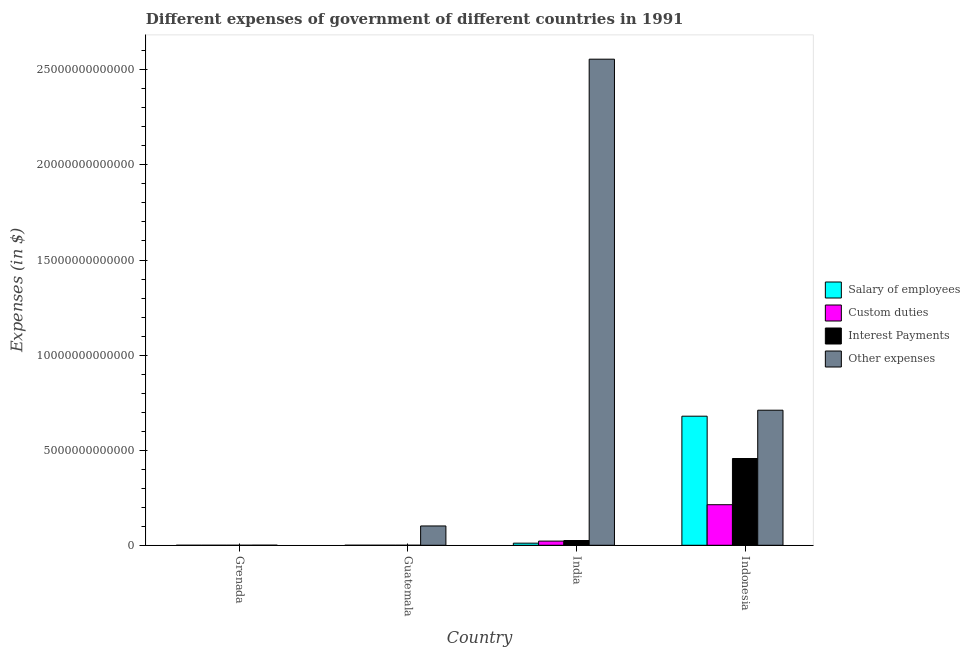How many different coloured bars are there?
Offer a very short reply. 4. How many groups of bars are there?
Ensure brevity in your answer.  4. Are the number of bars per tick equal to the number of legend labels?
Provide a short and direct response. Yes. Are the number of bars on each tick of the X-axis equal?
Your answer should be very brief. Yes. What is the label of the 2nd group of bars from the left?
Your response must be concise. Guatemala. What is the amount spent on interest payments in India?
Offer a terse response. 2.50e+11. Across all countries, what is the maximum amount spent on salary of employees?
Provide a succinct answer. 6.79e+12. Across all countries, what is the minimum amount spent on interest payments?
Provide a short and direct response. 1.28e+07. In which country was the amount spent on custom duties minimum?
Provide a short and direct response. Grenada. What is the total amount spent on salary of employees in the graph?
Your response must be concise. 6.90e+12. What is the difference between the amount spent on other expenses in Guatemala and that in Indonesia?
Provide a succinct answer. -6.09e+12. What is the difference between the amount spent on other expenses in Grenada and the amount spent on interest payments in Guatemala?
Your answer should be very brief. 3.11e+09. What is the average amount spent on salary of employees per country?
Your response must be concise. 1.72e+12. What is the difference between the amount spent on custom duties and amount spent on interest payments in Indonesia?
Keep it short and to the point. -2.43e+12. What is the ratio of the amount spent on salary of employees in Grenada to that in Guatemala?
Ensure brevity in your answer.  0.07. Is the amount spent on interest payments in Grenada less than that in Indonesia?
Give a very brief answer. Yes. Is the difference between the amount spent on custom duties in Guatemala and Indonesia greater than the difference between the amount spent on interest payments in Guatemala and Indonesia?
Provide a succinct answer. Yes. What is the difference between the highest and the second highest amount spent on salary of employees?
Provide a short and direct response. 6.68e+12. What is the difference between the highest and the lowest amount spent on custom duties?
Provide a succinct answer. 2.13e+12. Is the sum of the amount spent on custom duties in Guatemala and Indonesia greater than the maximum amount spent on salary of employees across all countries?
Provide a short and direct response. No. Is it the case that in every country, the sum of the amount spent on salary of employees and amount spent on interest payments is greater than the sum of amount spent on other expenses and amount spent on custom duties?
Provide a short and direct response. No. What does the 1st bar from the left in Guatemala represents?
Give a very brief answer. Salary of employees. What does the 2nd bar from the right in Guatemala represents?
Keep it short and to the point. Interest Payments. Is it the case that in every country, the sum of the amount spent on salary of employees and amount spent on custom duties is greater than the amount spent on interest payments?
Offer a very short reply. Yes. How many countries are there in the graph?
Make the answer very short. 4. What is the difference between two consecutive major ticks on the Y-axis?
Keep it short and to the point. 5.00e+12. Are the values on the major ticks of Y-axis written in scientific E-notation?
Your answer should be very brief. No. Does the graph contain any zero values?
Ensure brevity in your answer.  No. What is the title of the graph?
Give a very brief answer. Different expenses of government of different countries in 1991. Does "Tertiary education" appear as one of the legend labels in the graph?
Offer a terse response. No. What is the label or title of the X-axis?
Ensure brevity in your answer.  Country. What is the label or title of the Y-axis?
Give a very brief answer. Expenses (in $). What is the Expenses (in $) in Salary of employees in Grenada?
Provide a succinct answer. 9.53e+07. What is the Expenses (in $) in Custom duties in Grenada?
Ensure brevity in your answer.  3.07e+07. What is the Expenses (in $) in Interest Payments in Grenada?
Make the answer very short. 1.28e+07. What is the Expenses (in $) in Other expenses in Grenada?
Provide a short and direct response. 3.86e+09. What is the Expenses (in $) of Salary of employees in Guatemala?
Your response must be concise. 1.36e+09. What is the Expenses (in $) of Custom duties in Guatemala?
Offer a terse response. 6.62e+08. What is the Expenses (in $) of Interest Payments in Guatemala?
Offer a very short reply. 7.53e+08. What is the Expenses (in $) in Other expenses in Guatemala?
Your response must be concise. 1.02e+12. What is the Expenses (in $) of Salary of employees in India?
Provide a succinct answer. 1.11e+11. What is the Expenses (in $) in Custom duties in India?
Ensure brevity in your answer.  2.20e+11. What is the Expenses (in $) in Interest Payments in India?
Offer a very short reply. 2.50e+11. What is the Expenses (in $) in Other expenses in India?
Keep it short and to the point. 2.56e+13. What is the Expenses (in $) in Salary of employees in Indonesia?
Your response must be concise. 6.79e+12. What is the Expenses (in $) in Custom duties in Indonesia?
Make the answer very short. 2.13e+12. What is the Expenses (in $) of Interest Payments in Indonesia?
Make the answer very short. 4.56e+12. What is the Expenses (in $) in Other expenses in Indonesia?
Provide a succinct answer. 7.10e+12. Across all countries, what is the maximum Expenses (in $) of Salary of employees?
Provide a short and direct response. 6.79e+12. Across all countries, what is the maximum Expenses (in $) in Custom duties?
Provide a short and direct response. 2.13e+12. Across all countries, what is the maximum Expenses (in $) of Interest Payments?
Your response must be concise. 4.56e+12. Across all countries, what is the maximum Expenses (in $) in Other expenses?
Keep it short and to the point. 2.56e+13. Across all countries, what is the minimum Expenses (in $) in Salary of employees?
Ensure brevity in your answer.  9.53e+07. Across all countries, what is the minimum Expenses (in $) of Custom duties?
Offer a very short reply. 3.07e+07. Across all countries, what is the minimum Expenses (in $) of Interest Payments?
Offer a terse response. 1.28e+07. Across all countries, what is the minimum Expenses (in $) of Other expenses?
Ensure brevity in your answer.  3.86e+09. What is the total Expenses (in $) of Salary of employees in the graph?
Offer a terse response. 6.90e+12. What is the total Expenses (in $) of Custom duties in the graph?
Your response must be concise. 2.35e+12. What is the total Expenses (in $) of Interest Payments in the graph?
Offer a very short reply. 4.81e+12. What is the total Expenses (in $) in Other expenses in the graph?
Offer a very short reply. 3.37e+13. What is the difference between the Expenses (in $) in Salary of employees in Grenada and that in Guatemala?
Provide a short and direct response. -1.27e+09. What is the difference between the Expenses (in $) of Custom duties in Grenada and that in Guatemala?
Your answer should be compact. -6.31e+08. What is the difference between the Expenses (in $) in Interest Payments in Grenada and that in Guatemala?
Provide a short and direct response. -7.40e+08. What is the difference between the Expenses (in $) in Other expenses in Grenada and that in Guatemala?
Provide a short and direct response. -1.01e+12. What is the difference between the Expenses (in $) in Salary of employees in Grenada and that in India?
Give a very brief answer. -1.11e+11. What is the difference between the Expenses (in $) in Custom duties in Grenada and that in India?
Make the answer very short. -2.20e+11. What is the difference between the Expenses (in $) of Interest Payments in Grenada and that in India?
Your answer should be very brief. -2.50e+11. What is the difference between the Expenses (in $) of Other expenses in Grenada and that in India?
Provide a short and direct response. -2.56e+13. What is the difference between the Expenses (in $) in Salary of employees in Grenada and that in Indonesia?
Your response must be concise. -6.79e+12. What is the difference between the Expenses (in $) of Custom duties in Grenada and that in Indonesia?
Ensure brevity in your answer.  -2.13e+12. What is the difference between the Expenses (in $) of Interest Payments in Grenada and that in Indonesia?
Provide a succinct answer. -4.56e+12. What is the difference between the Expenses (in $) in Other expenses in Grenada and that in Indonesia?
Your answer should be very brief. -7.10e+12. What is the difference between the Expenses (in $) of Salary of employees in Guatemala and that in India?
Make the answer very short. -1.09e+11. What is the difference between the Expenses (in $) of Custom duties in Guatemala and that in India?
Offer a very short reply. -2.19e+11. What is the difference between the Expenses (in $) in Interest Payments in Guatemala and that in India?
Your response must be concise. -2.49e+11. What is the difference between the Expenses (in $) in Other expenses in Guatemala and that in India?
Ensure brevity in your answer.  -2.45e+13. What is the difference between the Expenses (in $) of Salary of employees in Guatemala and that in Indonesia?
Your answer should be compact. -6.79e+12. What is the difference between the Expenses (in $) in Custom duties in Guatemala and that in Indonesia?
Give a very brief answer. -2.13e+12. What is the difference between the Expenses (in $) of Interest Payments in Guatemala and that in Indonesia?
Your response must be concise. -4.56e+12. What is the difference between the Expenses (in $) in Other expenses in Guatemala and that in Indonesia?
Keep it short and to the point. -6.09e+12. What is the difference between the Expenses (in $) of Salary of employees in India and that in Indonesia?
Offer a very short reply. -6.68e+12. What is the difference between the Expenses (in $) of Custom duties in India and that in Indonesia?
Provide a short and direct response. -1.91e+12. What is the difference between the Expenses (in $) in Interest Payments in India and that in Indonesia?
Your answer should be very brief. -4.31e+12. What is the difference between the Expenses (in $) in Other expenses in India and that in Indonesia?
Ensure brevity in your answer.  1.85e+13. What is the difference between the Expenses (in $) of Salary of employees in Grenada and the Expenses (in $) of Custom duties in Guatemala?
Provide a succinct answer. -5.67e+08. What is the difference between the Expenses (in $) of Salary of employees in Grenada and the Expenses (in $) of Interest Payments in Guatemala?
Make the answer very short. -6.57e+08. What is the difference between the Expenses (in $) in Salary of employees in Grenada and the Expenses (in $) in Other expenses in Guatemala?
Provide a succinct answer. -1.02e+12. What is the difference between the Expenses (in $) of Custom duties in Grenada and the Expenses (in $) of Interest Payments in Guatemala?
Offer a terse response. -7.22e+08. What is the difference between the Expenses (in $) of Custom duties in Grenada and the Expenses (in $) of Other expenses in Guatemala?
Offer a terse response. -1.02e+12. What is the difference between the Expenses (in $) in Interest Payments in Grenada and the Expenses (in $) in Other expenses in Guatemala?
Your response must be concise. -1.02e+12. What is the difference between the Expenses (in $) of Salary of employees in Grenada and the Expenses (in $) of Custom duties in India?
Your response must be concise. -2.20e+11. What is the difference between the Expenses (in $) of Salary of employees in Grenada and the Expenses (in $) of Interest Payments in India?
Your answer should be very brief. -2.49e+11. What is the difference between the Expenses (in $) in Salary of employees in Grenada and the Expenses (in $) in Other expenses in India?
Ensure brevity in your answer.  -2.56e+13. What is the difference between the Expenses (in $) of Custom duties in Grenada and the Expenses (in $) of Interest Payments in India?
Offer a very short reply. -2.50e+11. What is the difference between the Expenses (in $) in Custom duties in Grenada and the Expenses (in $) in Other expenses in India?
Offer a very short reply. -2.56e+13. What is the difference between the Expenses (in $) of Interest Payments in Grenada and the Expenses (in $) of Other expenses in India?
Your answer should be very brief. -2.56e+13. What is the difference between the Expenses (in $) of Salary of employees in Grenada and the Expenses (in $) of Custom duties in Indonesia?
Offer a very short reply. -2.13e+12. What is the difference between the Expenses (in $) of Salary of employees in Grenada and the Expenses (in $) of Interest Payments in Indonesia?
Offer a terse response. -4.56e+12. What is the difference between the Expenses (in $) of Salary of employees in Grenada and the Expenses (in $) of Other expenses in Indonesia?
Your answer should be compact. -7.10e+12. What is the difference between the Expenses (in $) in Custom duties in Grenada and the Expenses (in $) in Interest Payments in Indonesia?
Offer a very short reply. -4.56e+12. What is the difference between the Expenses (in $) in Custom duties in Grenada and the Expenses (in $) in Other expenses in Indonesia?
Give a very brief answer. -7.10e+12. What is the difference between the Expenses (in $) in Interest Payments in Grenada and the Expenses (in $) in Other expenses in Indonesia?
Ensure brevity in your answer.  -7.10e+12. What is the difference between the Expenses (in $) of Salary of employees in Guatemala and the Expenses (in $) of Custom duties in India?
Your answer should be compact. -2.18e+11. What is the difference between the Expenses (in $) of Salary of employees in Guatemala and the Expenses (in $) of Interest Payments in India?
Provide a short and direct response. -2.48e+11. What is the difference between the Expenses (in $) of Salary of employees in Guatemala and the Expenses (in $) of Other expenses in India?
Your response must be concise. -2.56e+13. What is the difference between the Expenses (in $) in Custom duties in Guatemala and the Expenses (in $) in Interest Payments in India?
Give a very brief answer. -2.49e+11. What is the difference between the Expenses (in $) of Custom duties in Guatemala and the Expenses (in $) of Other expenses in India?
Provide a succinct answer. -2.56e+13. What is the difference between the Expenses (in $) of Interest Payments in Guatemala and the Expenses (in $) of Other expenses in India?
Make the answer very short. -2.56e+13. What is the difference between the Expenses (in $) of Salary of employees in Guatemala and the Expenses (in $) of Custom duties in Indonesia?
Provide a short and direct response. -2.13e+12. What is the difference between the Expenses (in $) of Salary of employees in Guatemala and the Expenses (in $) of Interest Payments in Indonesia?
Your response must be concise. -4.56e+12. What is the difference between the Expenses (in $) in Salary of employees in Guatemala and the Expenses (in $) in Other expenses in Indonesia?
Your answer should be very brief. -7.10e+12. What is the difference between the Expenses (in $) of Custom duties in Guatemala and the Expenses (in $) of Interest Payments in Indonesia?
Your answer should be compact. -4.56e+12. What is the difference between the Expenses (in $) of Custom duties in Guatemala and the Expenses (in $) of Other expenses in Indonesia?
Offer a very short reply. -7.10e+12. What is the difference between the Expenses (in $) in Interest Payments in Guatemala and the Expenses (in $) in Other expenses in Indonesia?
Your answer should be very brief. -7.10e+12. What is the difference between the Expenses (in $) of Salary of employees in India and the Expenses (in $) of Custom duties in Indonesia?
Give a very brief answer. -2.02e+12. What is the difference between the Expenses (in $) of Salary of employees in India and the Expenses (in $) of Interest Payments in Indonesia?
Offer a very short reply. -4.45e+12. What is the difference between the Expenses (in $) of Salary of employees in India and the Expenses (in $) of Other expenses in Indonesia?
Provide a succinct answer. -6.99e+12. What is the difference between the Expenses (in $) of Custom duties in India and the Expenses (in $) of Interest Payments in Indonesia?
Your response must be concise. -4.34e+12. What is the difference between the Expenses (in $) in Custom duties in India and the Expenses (in $) in Other expenses in Indonesia?
Your response must be concise. -6.88e+12. What is the difference between the Expenses (in $) in Interest Payments in India and the Expenses (in $) in Other expenses in Indonesia?
Offer a terse response. -6.85e+12. What is the average Expenses (in $) in Salary of employees per country?
Ensure brevity in your answer.  1.72e+12. What is the average Expenses (in $) of Custom duties per country?
Offer a very short reply. 5.88e+11. What is the average Expenses (in $) in Interest Payments per country?
Offer a very short reply. 1.20e+12. What is the average Expenses (in $) of Other expenses per country?
Offer a very short reply. 8.42e+12. What is the difference between the Expenses (in $) in Salary of employees and Expenses (in $) in Custom duties in Grenada?
Give a very brief answer. 6.46e+07. What is the difference between the Expenses (in $) in Salary of employees and Expenses (in $) in Interest Payments in Grenada?
Keep it short and to the point. 8.24e+07. What is the difference between the Expenses (in $) of Salary of employees and Expenses (in $) of Other expenses in Grenada?
Provide a short and direct response. -3.76e+09. What is the difference between the Expenses (in $) in Custom duties and Expenses (in $) in Interest Payments in Grenada?
Keep it short and to the point. 1.79e+07. What is the difference between the Expenses (in $) in Custom duties and Expenses (in $) in Other expenses in Grenada?
Your answer should be very brief. -3.83e+09. What is the difference between the Expenses (in $) in Interest Payments and Expenses (in $) in Other expenses in Grenada?
Provide a short and direct response. -3.85e+09. What is the difference between the Expenses (in $) of Salary of employees and Expenses (in $) of Custom duties in Guatemala?
Give a very brief answer. 7.02e+08. What is the difference between the Expenses (in $) in Salary of employees and Expenses (in $) in Interest Payments in Guatemala?
Offer a very short reply. 6.12e+08. What is the difference between the Expenses (in $) of Salary of employees and Expenses (in $) of Other expenses in Guatemala?
Your response must be concise. -1.01e+12. What is the difference between the Expenses (in $) in Custom duties and Expenses (in $) in Interest Payments in Guatemala?
Your response must be concise. -9.05e+07. What is the difference between the Expenses (in $) in Custom duties and Expenses (in $) in Other expenses in Guatemala?
Give a very brief answer. -1.02e+12. What is the difference between the Expenses (in $) of Interest Payments and Expenses (in $) of Other expenses in Guatemala?
Offer a terse response. -1.02e+12. What is the difference between the Expenses (in $) of Salary of employees and Expenses (in $) of Custom duties in India?
Make the answer very short. -1.09e+11. What is the difference between the Expenses (in $) of Salary of employees and Expenses (in $) of Interest Payments in India?
Offer a terse response. -1.39e+11. What is the difference between the Expenses (in $) in Salary of employees and Expenses (in $) in Other expenses in India?
Make the answer very short. -2.54e+13. What is the difference between the Expenses (in $) in Custom duties and Expenses (in $) in Interest Payments in India?
Give a very brief answer. -2.98e+1. What is the difference between the Expenses (in $) in Custom duties and Expenses (in $) in Other expenses in India?
Your answer should be very brief. -2.53e+13. What is the difference between the Expenses (in $) of Interest Payments and Expenses (in $) of Other expenses in India?
Your answer should be very brief. -2.53e+13. What is the difference between the Expenses (in $) in Salary of employees and Expenses (in $) in Custom duties in Indonesia?
Ensure brevity in your answer.  4.65e+12. What is the difference between the Expenses (in $) of Salary of employees and Expenses (in $) of Interest Payments in Indonesia?
Your answer should be compact. 2.22e+12. What is the difference between the Expenses (in $) in Salary of employees and Expenses (in $) in Other expenses in Indonesia?
Keep it short and to the point. -3.15e+11. What is the difference between the Expenses (in $) of Custom duties and Expenses (in $) of Interest Payments in Indonesia?
Keep it short and to the point. -2.43e+12. What is the difference between the Expenses (in $) in Custom duties and Expenses (in $) in Other expenses in Indonesia?
Your response must be concise. -4.97e+12. What is the difference between the Expenses (in $) in Interest Payments and Expenses (in $) in Other expenses in Indonesia?
Your response must be concise. -2.54e+12. What is the ratio of the Expenses (in $) in Salary of employees in Grenada to that in Guatemala?
Your response must be concise. 0.07. What is the ratio of the Expenses (in $) of Custom duties in Grenada to that in Guatemala?
Offer a terse response. 0.05. What is the ratio of the Expenses (in $) of Interest Payments in Grenada to that in Guatemala?
Provide a short and direct response. 0.02. What is the ratio of the Expenses (in $) in Other expenses in Grenada to that in Guatemala?
Provide a succinct answer. 0. What is the ratio of the Expenses (in $) in Salary of employees in Grenada to that in India?
Provide a succinct answer. 0. What is the ratio of the Expenses (in $) in Interest Payments in Grenada to that in India?
Keep it short and to the point. 0. What is the ratio of the Expenses (in $) in Other expenses in Grenada to that in India?
Make the answer very short. 0. What is the ratio of the Expenses (in $) in Salary of employees in Grenada to that in Indonesia?
Ensure brevity in your answer.  0. What is the ratio of the Expenses (in $) of Custom duties in Grenada to that in Indonesia?
Your response must be concise. 0. What is the ratio of the Expenses (in $) in Other expenses in Grenada to that in Indonesia?
Your answer should be compact. 0. What is the ratio of the Expenses (in $) of Salary of employees in Guatemala to that in India?
Provide a short and direct response. 0.01. What is the ratio of the Expenses (in $) of Custom duties in Guatemala to that in India?
Give a very brief answer. 0. What is the ratio of the Expenses (in $) of Interest Payments in Guatemala to that in India?
Provide a succinct answer. 0. What is the ratio of the Expenses (in $) in Other expenses in Guatemala to that in India?
Provide a short and direct response. 0.04. What is the ratio of the Expenses (in $) in Salary of employees in Guatemala to that in Indonesia?
Provide a short and direct response. 0. What is the ratio of the Expenses (in $) in Custom duties in Guatemala to that in Indonesia?
Provide a succinct answer. 0. What is the ratio of the Expenses (in $) of Other expenses in Guatemala to that in Indonesia?
Your answer should be very brief. 0.14. What is the ratio of the Expenses (in $) in Salary of employees in India to that in Indonesia?
Ensure brevity in your answer.  0.02. What is the ratio of the Expenses (in $) in Custom duties in India to that in Indonesia?
Provide a short and direct response. 0.1. What is the ratio of the Expenses (in $) in Interest Payments in India to that in Indonesia?
Make the answer very short. 0.05. What is the ratio of the Expenses (in $) of Other expenses in India to that in Indonesia?
Your answer should be compact. 3.6. What is the difference between the highest and the second highest Expenses (in $) in Salary of employees?
Give a very brief answer. 6.68e+12. What is the difference between the highest and the second highest Expenses (in $) in Custom duties?
Your response must be concise. 1.91e+12. What is the difference between the highest and the second highest Expenses (in $) in Interest Payments?
Your answer should be very brief. 4.31e+12. What is the difference between the highest and the second highest Expenses (in $) in Other expenses?
Provide a short and direct response. 1.85e+13. What is the difference between the highest and the lowest Expenses (in $) of Salary of employees?
Keep it short and to the point. 6.79e+12. What is the difference between the highest and the lowest Expenses (in $) in Custom duties?
Your answer should be very brief. 2.13e+12. What is the difference between the highest and the lowest Expenses (in $) of Interest Payments?
Provide a succinct answer. 4.56e+12. What is the difference between the highest and the lowest Expenses (in $) of Other expenses?
Provide a short and direct response. 2.56e+13. 